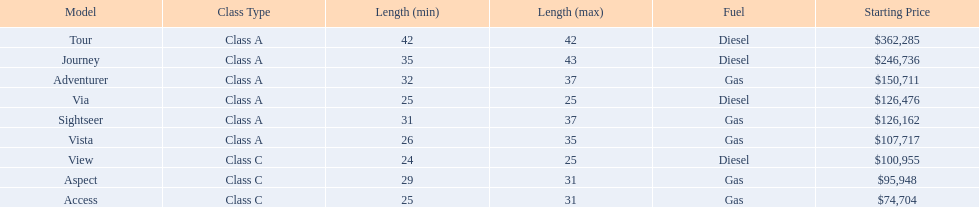Which of the models in the table use diesel fuel? Tour, Journey, Via, View. Of these models, which are class a? Tour, Journey, Via. Which of them are greater than 35' in length? Tour, Journey. Which of the two models is more expensive? Tour. 